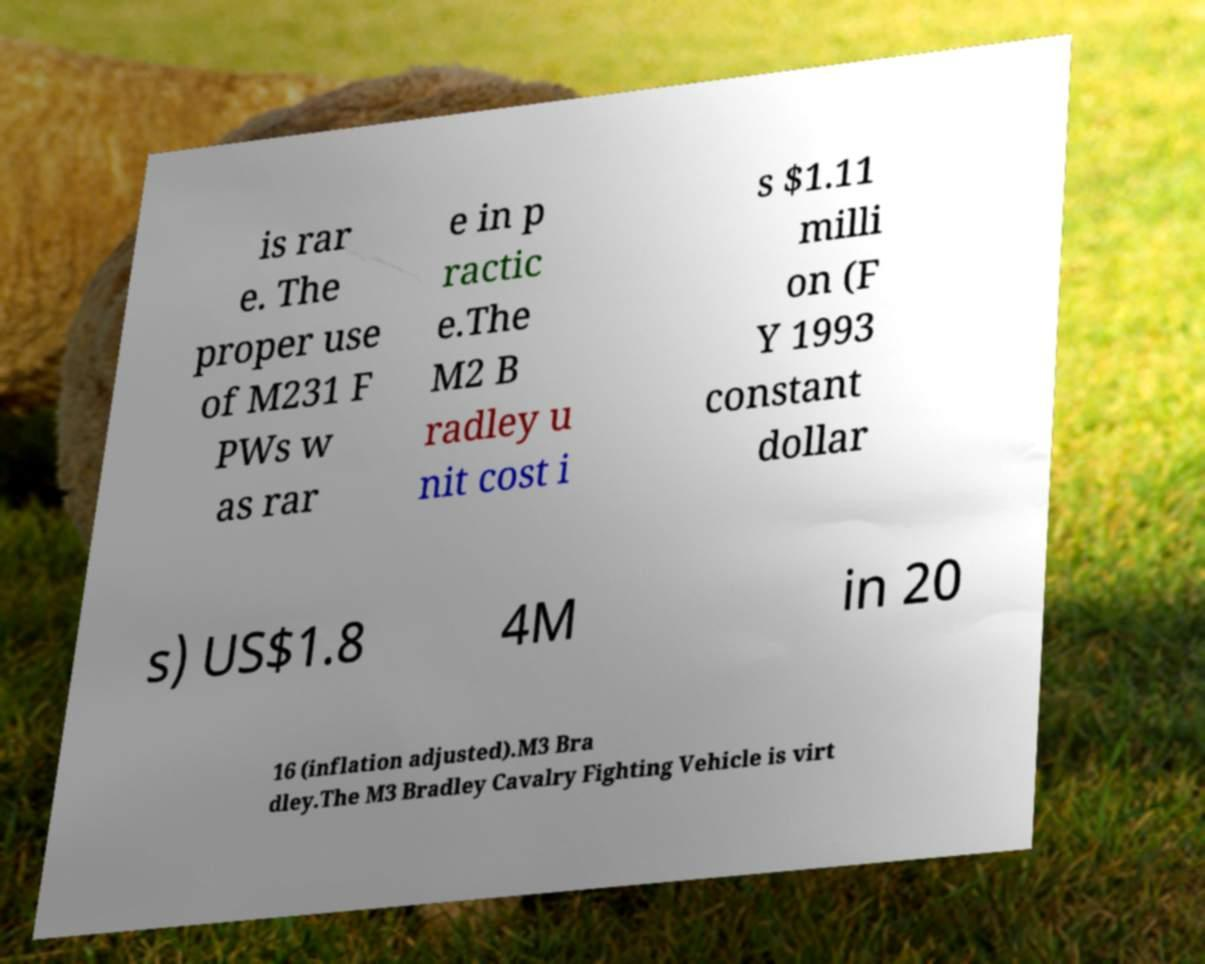Could you assist in decoding the text presented in this image and type it out clearly? is rar e. The proper use of M231 F PWs w as rar e in p ractic e.The M2 B radley u nit cost i s $1.11 milli on (F Y 1993 constant dollar s) US$1.8 4M in 20 16 (inflation adjusted).M3 Bra dley.The M3 Bradley Cavalry Fighting Vehicle is virt 